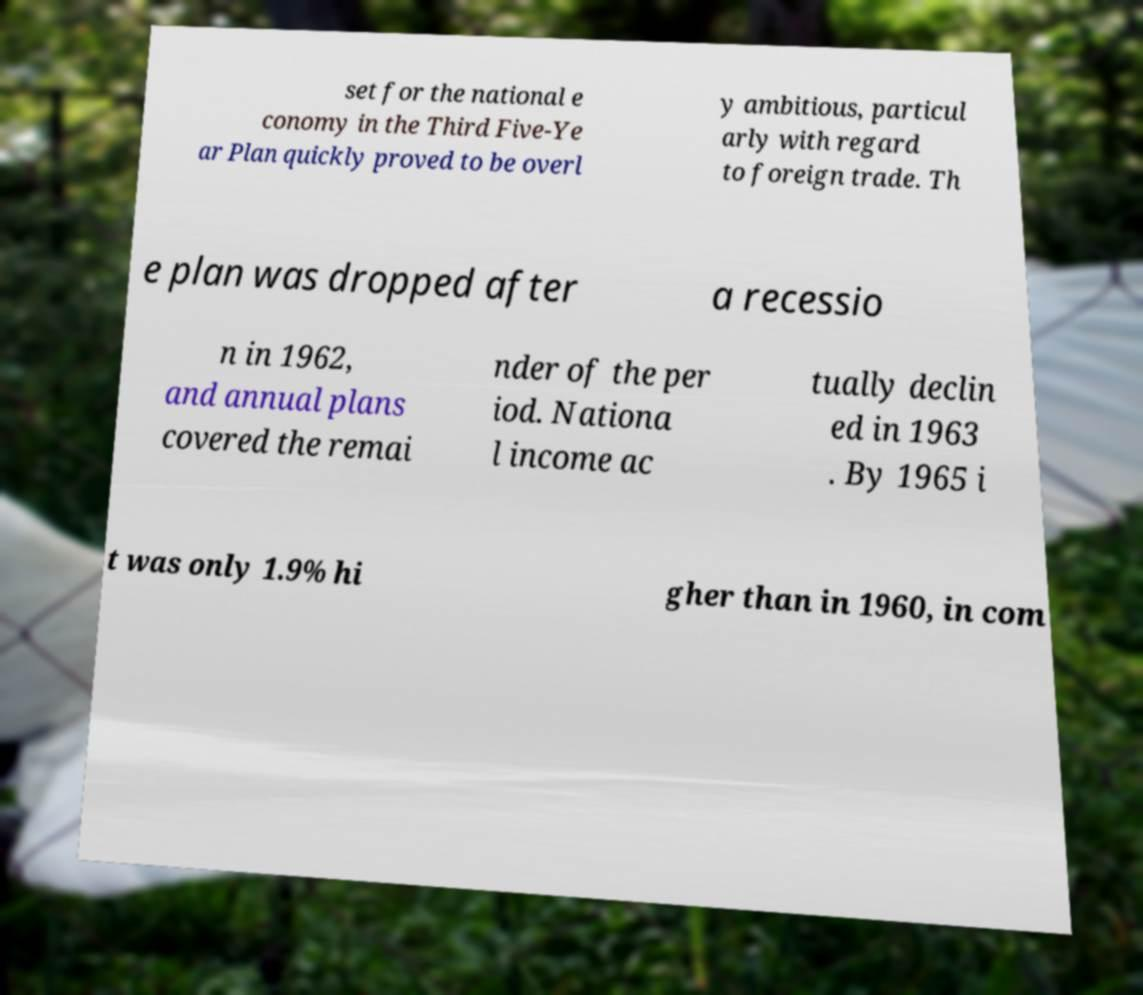I need the written content from this picture converted into text. Can you do that? set for the national e conomy in the Third Five-Ye ar Plan quickly proved to be overl y ambitious, particul arly with regard to foreign trade. Th e plan was dropped after a recessio n in 1962, and annual plans covered the remai nder of the per iod. Nationa l income ac tually declin ed in 1963 . By 1965 i t was only 1.9% hi gher than in 1960, in com 